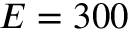<formula> <loc_0><loc_0><loc_500><loc_500>E = 3 0 0</formula> 